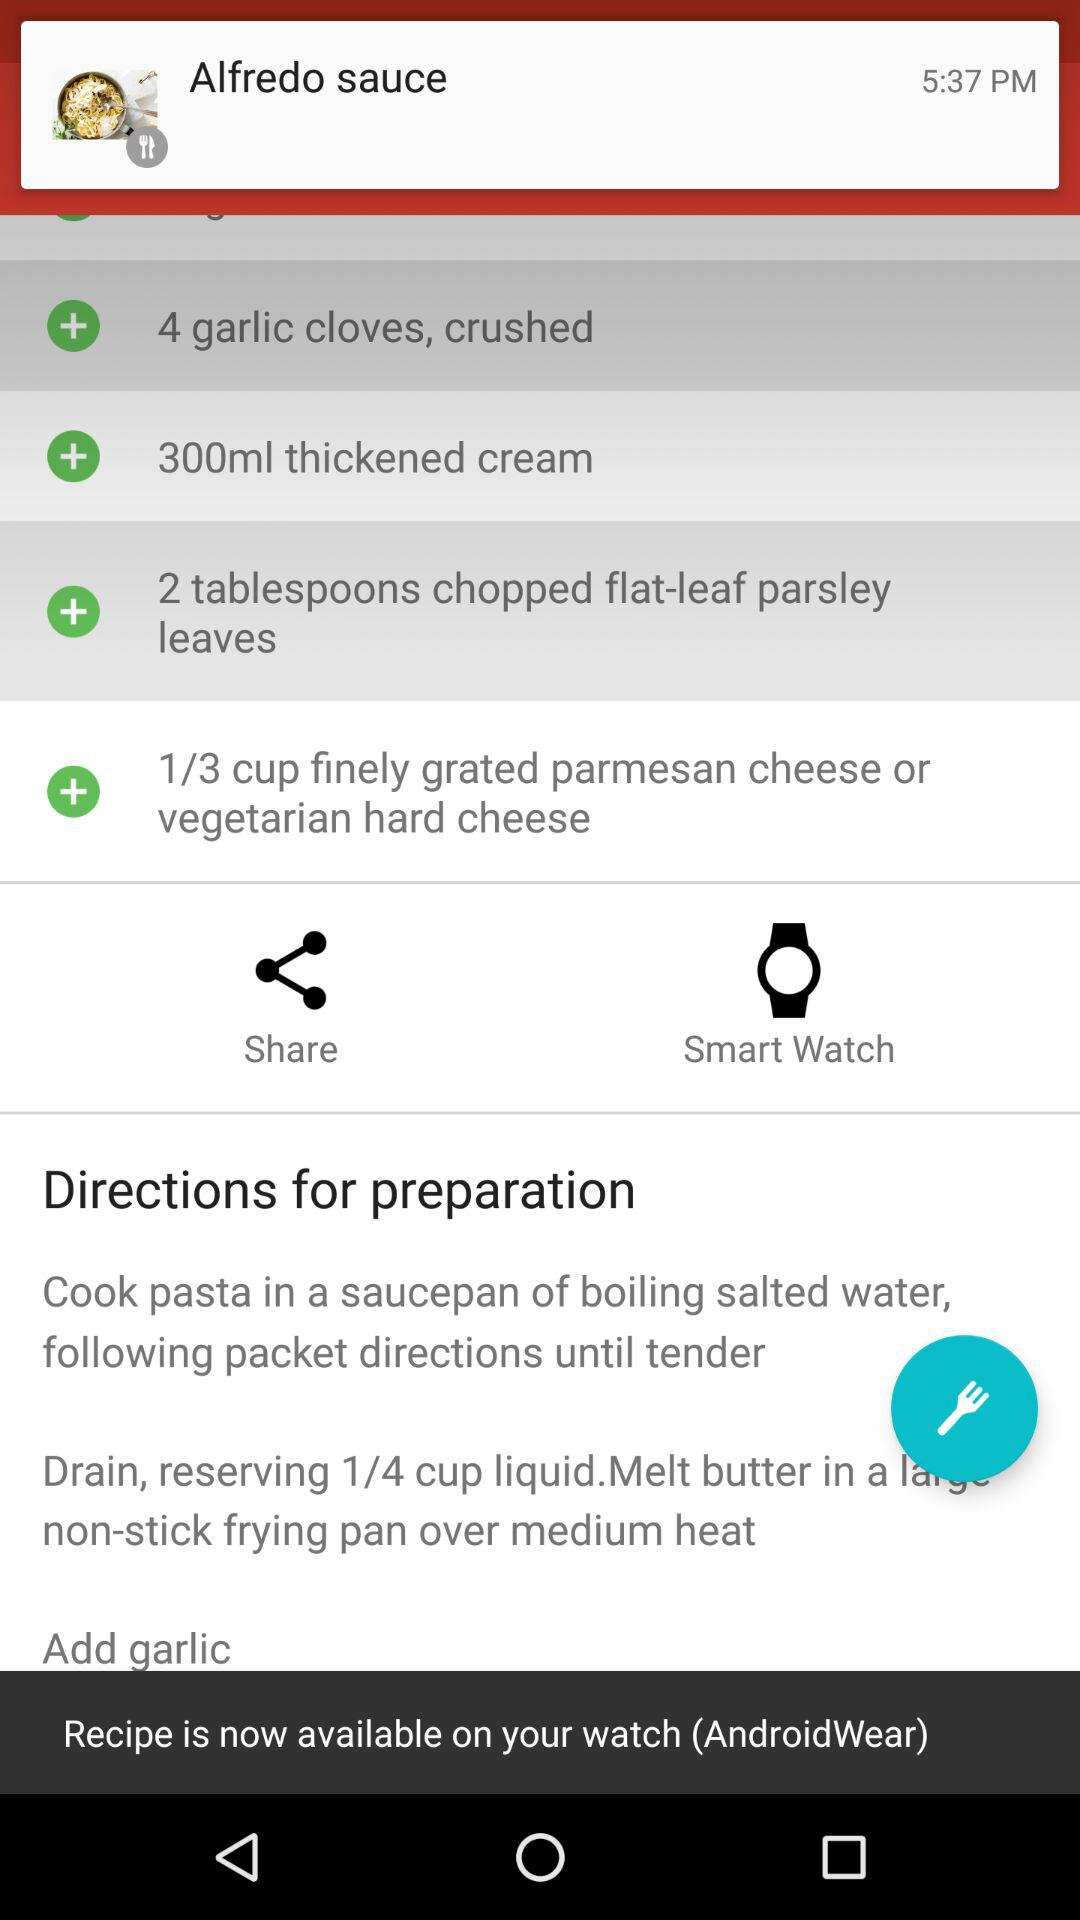How much finely grated cheese is required? The finely grated cheese required is 1/3 cup. 